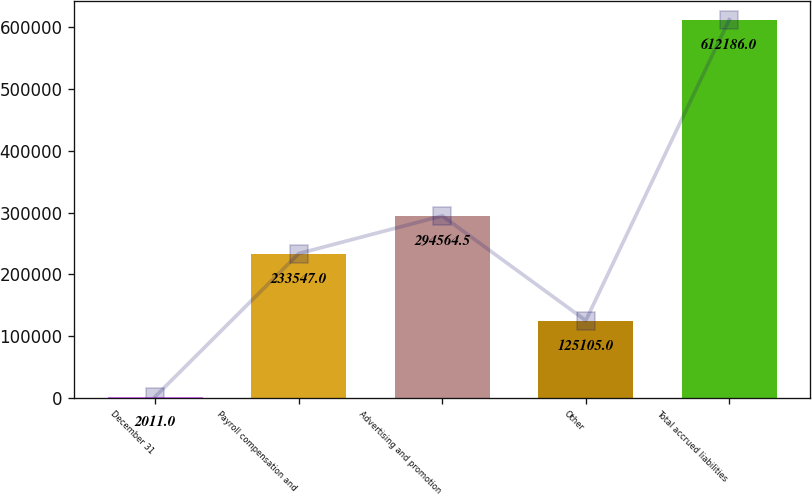Convert chart. <chart><loc_0><loc_0><loc_500><loc_500><bar_chart><fcel>December 31<fcel>Payroll compensation and<fcel>Advertising and promotion<fcel>Other<fcel>Total accrued liabilities<nl><fcel>2011<fcel>233547<fcel>294564<fcel>125105<fcel>612186<nl></chart> 